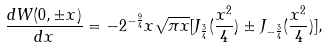Convert formula to latex. <formula><loc_0><loc_0><loc_500><loc_500>\frac { d W ( 0 , \pm x ) } { d x } = - 2 ^ { - \frac { 9 } { 4 } } x \sqrt { \pi x } [ J _ { \frac { 3 } { 4 } } ( \frac { x ^ { 2 } } { 4 } ) \pm J _ { - \frac { 3 } { 4 } } ( \frac { x ^ { 2 } } { 4 } ) ] ,</formula> 